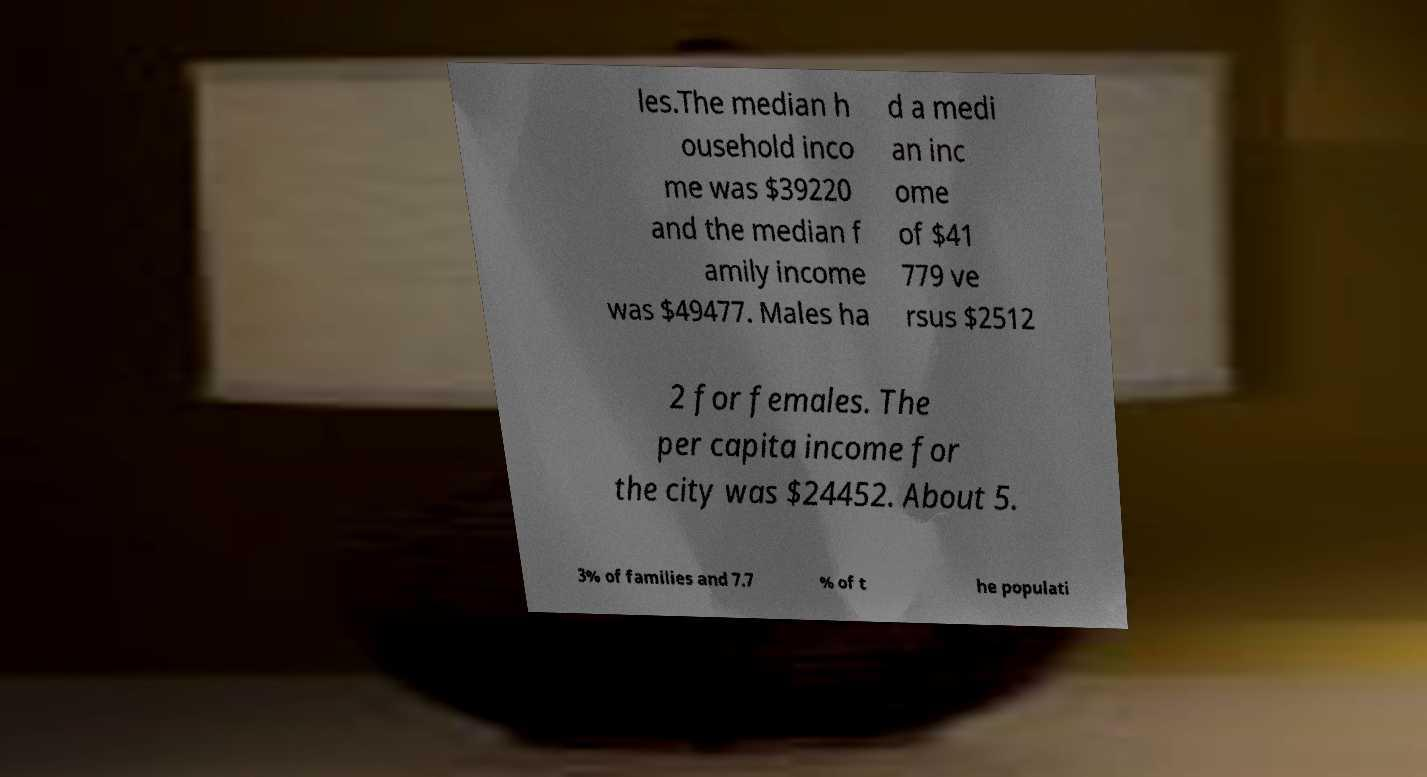Please identify and transcribe the text found in this image. les.The median h ousehold inco me was $39220 and the median f amily income was $49477. Males ha d a medi an inc ome of $41 779 ve rsus $2512 2 for females. The per capita income for the city was $24452. About 5. 3% of families and 7.7 % of t he populati 